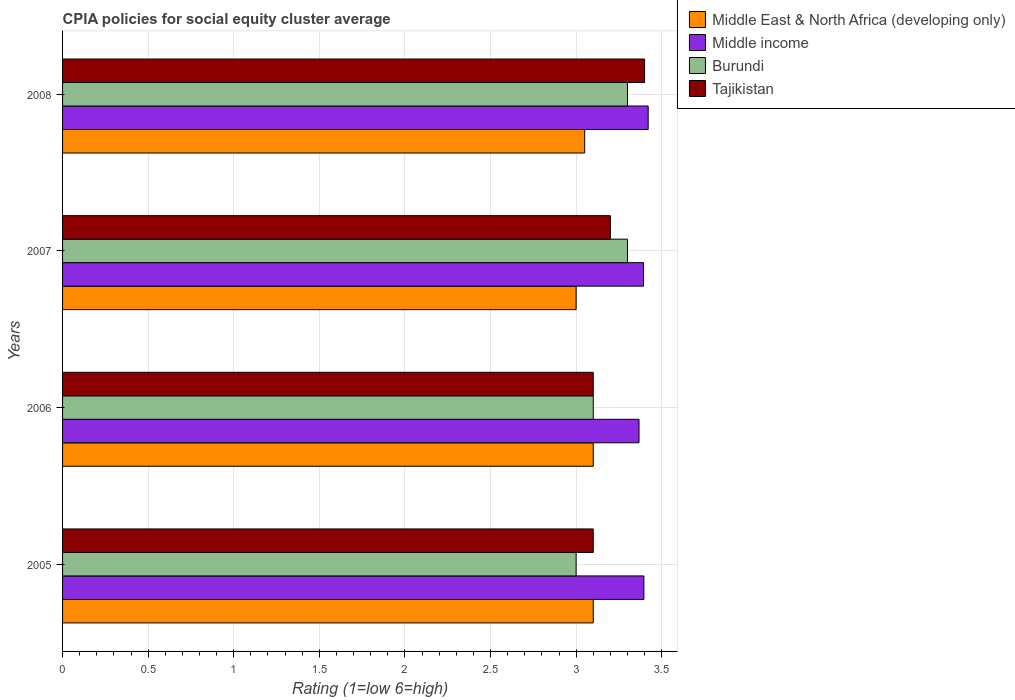Are the number of bars per tick equal to the number of legend labels?
Ensure brevity in your answer.  Yes. How many bars are there on the 1st tick from the bottom?
Provide a short and direct response. 4. In which year was the CPIA rating in Middle East & North Africa (developing only) minimum?
Make the answer very short. 2007. What is the difference between the CPIA rating in Middle East & North Africa (developing only) in 2005 and that in 2008?
Offer a very short reply. 0.05. What is the difference between the CPIA rating in Middle East & North Africa (developing only) in 2005 and the CPIA rating in Middle income in 2007?
Your answer should be very brief. -0.29. What is the average CPIA rating in Burundi per year?
Give a very brief answer. 3.17. In the year 2005, what is the difference between the CPIA rating in Burundi and CPIA rating in Middle East & North Africa (developing only)?
Provide a succinct answer. -0.1. What is the ratio of the CPIA rating in Middle income in 2007 to that in 2008?
Keep it short and to the point. 0.99. Is the difference between the CPIA rating in Burundi in 2005 and 2006 greater than the difference between the CPIA rating in Middle East & North Africa (developing only) in 2005 and 2006?
Provide a short and direct response. No. What is the difference between the highest and the lowest CPIA rating in Middle income?
Provide a short and direct response. 0.05. In how many years, is the CPIA rating in Middle East & North Africa (developing only) greater than the average CPIA rating in Middle East & North Africa (developing only) taken over all years?
Keep it short and to the point. 2. What does the 4th bar from the top in 2005 represents?
Your response must be concise. Middle East & North Africa (developing only). What does the 4th bar from the bottom in 2005 represents?
Your answer should be compact. Tajikistan. Are all the bars in the graph horizontal?
Your answer should be compact. Yes. How many years are there in the graph?
Give a very brief answer. 4. What is the difference between two consecutive major ticks on the X-axis?
Ensure brevity in your answer.  0.5. Where does the legend appear in the graph?
Offer a very short reply. Top right. What is the title of the graph?
Your response must be concise. CPIA policies for social equity cluster average. Does "Norway" appear as one of the legend labels in the graph?
Your answer should be compact. No. What is the Rating (1=low 6=high) of Middle income in 2005?
Ensure brevity in your answer.  3.4. What is the Rating (1=low 6=high) in Tajikistan in 2005?
Give a very brief answer. 3.1. What is the Rating (1=low 6=high) in Middle income in 2006?
Your answer should be very brief. 3.37. What is the Rating (1=low 6=high) in Middle East & North Africa (developing only) in 2007?
Offer a terse response. 3. What is the Rating (1=low 6=high) of Middle income in 2007?
Your response must be concise. 3.39. What is the Rating (1=low 6=high) in Burundi in 2007?
Provide a short and direct response. 3.3. What is the Rating (1=low 6=high) of Middle East & North Africa (developing only) in 2008?
Make the answer very short. 3.05. What is the Rating (1=low 6=high) in Middle income in 2008?
Your answer should be compact. 3.42. What is the Rating (1=low 6=high) in Burundi in 2008?
Offer a very short reply. 3.3. What is the Rating (1=low 6=high) of Tajikistan in 2008?
Offer a very short reply. 3.4. Across all years, what is the maximum Rating (1=low 6=high) of Middle income?
Keep it short and to the point. 3.42. Across all years, what is the maximum Rating (1=low 6=high) in Burundi?
Your response must be concise. 3.3. Across all years, what is the minimum Rating (1=low 6=high) in Middle East & North Africa (developing only)?
Provide a short and direct response. 3. Across all years, what is the minimum Rating (1=low 6=high) in Middle income?
Provide a short and direct response. 3.37. Across all years, what is the minimum Rating (1=low 6=high) in Tajikistan?
Ensure brevity in your answer.  3.1. What is the total Rating (1=low 6=high) in Middle East & North Africa (developing only) in the graph?
Your answer should be very brief. 12.25. What is the total Rating (1=low 6=high) of Middle income in the graph?
Provide a short and direct response. 13.58. What is the total Rating (1=low 6=high) of Tajikistan in the graph?
Ensure brevity in your answer.  12.8. What is the difference between the Rating (1=low 6=high) in Middle income in 2005 and that in 2006?
Make the answer very short. 0.03. What is the difference between the Rating (1=low 6=high) in Burundi in 2005 and that in 2006?
Offer a very short reply. -0.1. What is the difference between the Rating (1=low 6=high) of Tajikistan in 2005 and that in 2006?
Offer a very short reply. 0. What is the difference between the Rating (1=low 6=high) in Middle East & North Africa (developing only) in 2005 and that in 2007?
Offer a very short reply. 0.1. What is the difference between the Rating (1=low 6=high) in Middle income in 2005 and that in 2007?
Your answer should be very brief. 0. What is the difference between the Rating (1=low 6=high) of Burundi in 2005 and that in 2007?
Make the answer very short. -0.3. What is the difference between the Rating (1=low 6=high) of Tajikistan in 2005 and that in 2007?
Provide a succinct answer. -0.1. What is the difference between the Rating (1=low 6=high) in Middle income in 2005 and that in 2008?
Offer a very short reply. -0.03. What is the difference between the Rating (1=low 6=high) in Middle East & North Africa (developing only) in 2006 and that in 2007?
Offer a terse response. 0.1. What is the difference between the Rating (1=low 6=high) of Middle income in 2006 and that in 2007?
Give a very brief answer. -0.03. What is the difference between the Rating (1=low 6=high) of Burundi in 2006 and that in 2007?
Make the answer very short. -0.2. What is the difference between the Rating (1=low 6=high) of Tajikistan in 2006 and that in 2007?
Your response must be concise. -0.1. What is the difference between the Rating (1=low 6=high) of Middle East & North Africa (developing only) in 2006 and that in 2008?
Give a very brief answer. 0.05. What is the difference between the Rating (1=low 6=high) in Middle income in 2006 and that in 2008?
Your answer should be compact. -0.05. What is the difference between the Rating (1=low 6=high) in Tajikistan in 2006 and that in 2008?
Keep it short and to the point. -0.3. What is the difference between the Rating (1=low 6=high) in Middle East & North Africa (developing only) in 2007 and that in 2008?
Provide a short and direct response. -0.05. What is the difference between the Rating (1=low 6=high) of Middle income in 2007 and that in 2008?
Your answer should be compact. -0.03. What is the difference between the Rating (1=low 6=high) in Tajikistan in 2007 and that in 2008?
Keep it short and to the point. -0.2. What is the difference between the Rating (1=low 6=high) in Middle East & North Africa (developing only) in 2005 and the Rating (1=low 6=high) in Middle income in 2006?
Provide a succinct answer. -0.27. What is the difference between the Rating (1=low 6=high) in Middle East & North Africa (developing only) in 2005 and the Rating (1=low 6=high) in Burundi in 2006?
Keep it short and to the point. 0. What is the difference between the Rating (1=low 6=high) of Middle East & North Africa (developing only) in 2005 and the Rating (1=low 6=high) of Tajikistan in 2006?
Ensure brevity in your answer.  0. What is the difference between the Rating (1=low 6=high) of Middle income in 2005 and the Rating (1=low 6=high) of Burundi in 2006?
Ensure brevity in your answer.  0.3. What is the difference between the Rating (1=low 6=high) in Middle income in 2005 and the Rating (1=low 6=high) in Tajikistan in 2006?
Provide a short and direct response. 0.3. What is the difference between the Rating (1=low 6=high) in Burundi in 2005 and the Rating (1=low 6=high) in Tajikistan in 2006?
Provide a succinct answer. -0.1. What is the difference between the Rating (1=low 6=high) of Middle East & North Africa (developing only) in 2005 and the Rating (1=low 6=high) of Middle income in 2007?
Make the answer very short. -0.29. What is the difference between the Rating (1=low 6=high) of Middle East & North Africa (developing only) in 2005 and the Rating (1=low 6=high) of Tajikistan in 2007?
Your answer should be very brief. -0.1. What is the difference between the Rating (1=low 6=high) of Middle income in 2005 and the Rating (1=low 6=high) of Burundi in 2007?
Your answer should be very brief. 0.1. What is the difference between the Rating (1=low 6=high) in Middle income in 2005 and the Rating (1=low 6=high) in Tajikistan in 2007?
Your answer should be very brief. 0.2. What is the difference between the Rating (1=low 6=high) in Burundi in 2005 and the Rating (1=low 6=high) in Tajikistan in 2007?
Keep it short and to the point. -0.2. What is the difference between the Rating (1=low 6=high) of Middle East & North Africa (developing only) in 2005 and the Rating (1=low 6=high) of Middle income in 2008?
Your answer should be very brief. -0.32. What is the difference between the Rating (1=low 6=high) of Middle East & North Africa (developing only) in 2005 and the Rating (1=low 6=high) of Burundi in 2008?
Provide a short and direct response. -0.2. What is the difference between the Rating (1=low 6=high) of Middle East & North Africa (developing only) in 2005 and the Rating (1=low 6=high) of Tajikistan in 2008?
Make the answer very short. -0.3. What is the difference between the Rating (1=low 6=high) in Middle income in 2005 and the Rating (1=low 6=high) in Burundi in 2008?
Your response must be concise. 0.1. What is the difference between the Rating (1=low 6=high) of Middle income in 2005 and the Rating (1=low 6=high) of Tajikistan in 2008?
Give a very brief answer. -0. What is the difference between the Rating (1=low 6=high) of Burundi in 2005 and the Rating (1=low 6=high) of Tajikistan in 2008?
Provide a succinct answer. -0.4. What is the difference between the Rating (1=low 6=high) in Middle East & North Africa (developing only) in 2006 and the Rating (1=low 6=high) in Middle income in 2007?
Your answer should be very brief. -0.29. What is the difference between the Rating (1=low 6=high) in Middle East & North Africa (developing only) in 2006 and the Rating (1=low 6=high) in Burundi in 2007?
Provide a succinct answer. -0.2. What is the difference between the Rating (1=low 6=high) of Middle income in 2006 and the Rating (1=low 6=high) of Burundi in 2007?
Your response must be concise. 0.07. What is the difference between the Rating (1=low 6=high) in Middle income in 2006 and the Rating (1=low 6=high) in Tajikistan in 2007?
Your answer should be compact. 0.17. What is the difference between the Rating (1=low 6=high) of Middle East & North Africa (developing only) in 2006 and the Rating (1=low 6=high) of Middle income in 2008?
Provide a short and direct response. -0.32. What is the difference between the Rating (1=low 6=high) in Middle income in 2006 and the Rating (1=low 6=high) in Burundi in 2008?
Your answer should be compact. 0.07. What is the difference between the Rating (1=low 6=high) in Middle income in 2006 and the Rating (1=low 6=high) in Tajikistan in 2008?
Make the answer very short. -0.03. What is the difference between the Rating (1=low 6=high) in Middle East & North Africa (developing only) in 2007 and the Rating (1=low 6=high) in Middle income in 2008?
Provide a short and direct response. -0.42. What is the difference between the Rating (1=low 6=high) of Middle East & North Africa (developing only) in 2007 and the Rating (1=low 6=high) of Burundi in 2008?
Your response must be concise. -0.3. What is the difference between the Rating (1=low 6=high) in Middle income in 2007 and the Rating (1=low 6=high) in Burundi in 2008?
Offer a very short reply. 0.09. What is the difference between the Rating (1=low 6=high) of Middle income in 2007 and the Rating (1=low 6=high) of Tajikistan in 2008?
Offer a terse response. -0.01. What is the average Rating (1=low 6=high) in Middle East & North Africa (developing only) per year?
Give a very brief answer. 3.06. What is the average Rating (1=low 6=high) in Middle income per year?
Offer a terse response. 3.39. What is the average Rating (1=low 6=high) in Burundi per year?
Offer a very short reply. 3.17. In the year 2005, what is the difference between the Rating (1=low 6=high) in Middle East & North Africa (developing only) and Rating (1=low 6=high) in Middle income?
Provide a succinct answer. -0.3. In the year 2005, what is the difference between the Rating (1=low 6=high) in Middle East & North Africa (developing only) and Rating (1=low 6=high) in Tajikistan?
Give a very brief answer. 0. In the year 2005, what is the difference between the Rating (1=low 6=high) of Middle income and Rating (1=low 6=high) of Burundi?
Your response must be concise. 0.4. In the year 2005, what is the difference between the Rating (1=low 6=high) of Middle income and Rating (1=low 6=high) of Tajikistan?
Offer a terse response. 0.3. In the year 2006, what is the difference between the Rating (1=low 6=high) in Middle East & North Africa (developing only) and Rating (1=low 6=high) in Middle income?
Provide a succinct answer. -0.27. In the year 2006, what is the difference between the Rating (1=low 6=high) of Middle East & North Africa (developing only) and Rating (1=low 6=high) of Tajikistan?
Keep it short and to the point. 0. In the year 2006, what is the difference between the Rating (1=low 6=high) in Middle income and Rating (1=low 6=high) in Burundi?
Provide a succinct answer. 0.27. In the year 2006, what is the difference between the Rating (1=low 6=high) of Middle income and Rating (1=low 6=high) of Tajikistan?
Keep it short and to the point. 0.27. In the year 2006, what is the difference between the Rating (1=low 6=high) of Burundi and Rating (1=low 6=high) of Tajikistan?
Offer a terse response. 0. In the year 2007, what is the difference between the Rating (1=low 6=high) of Middle East & North Africa (developing only) and Rating (1=low 6=high) of Middle income?
Keep it short and to the point. -0.39. In the year 2007, what is the difference between the Rating (1=low 6=high) of Middle East & North Africa (developing only) and Rating (1=low 6=high) of Tajikistan?
Provide a short and direct response. -0.2. In the year 2007, what is the difference between the Rating (1=low 6=high) in Middle income and Rating (1=low 6=high) in Burundi?
Keep it short and to the point. 0.09. In the year 2007, what is the difference between the Rating (1=low 6=high) of Middle income and Rating (1=low 6=high) of Tajikistan?
Offer a terse response. 0.19. In the year 2007, what is the difference between the Rating (1=low 6=high) of Burundi and Rating (1=low 6=high) of Tajikistan?
Keep it short and to the point. 0.1. In the year 2008, what is the difference between the Rating (1=low 6=high) in Middle East & North Africa (developing only) and Rating (1=low 6=high) in Middle income?
Provide a short and direct response. -0.37. In the year 2008, what is the difference between the Rating (1=low 6=high) in Middle East & North Africa (developing only) and Rating (1=low 6=high) in Tajikistan?
Your response must be concise. -0.35. In the year 2008, what is the difference between the Rating (1=low 6=high) in Middle income and Rating (1=low 6=high) in Burundi?
Your response must be concise. 0.12. In the year 2008, what is the difference between the Rating (1=low 6=high) of Middle income and Rating (1=low 6=high) of Tajikistan?
Make the answer very short. 0.02. In the year 2008, what is the difference between the Rating (1=low 6=high) in Burundi and Rating (1=low 6=high) in Tajikistan?
Provide a short and direct response. -0.1. What is the ratio of the Rating (1=low 6=high) of Middle East & North Africa (developing only) in 2005 to that in 2006?
Provide a short and direct response. 1. What is the ratio of the Rating (1=low 6=high) of Middle income in 2005 to that in 2006?
Give a very brief answer. 1.01. What is the ratio of the Rating (1=low 6=high) in Tajikistan in 2005 to that in 2006?
Give a very brief answer. 1. What is the ratio of the Rating (1=low 6=high) of Tajikistan in 2005 to that in 2007?
Offer a very short reply. 0.97. What is the ratio of the Rating (1=low 6=high) in Middle East & North Africa (developing only) in 2005 to that in 2008?
Give a very brief answer. 1.02. What is the ratio of the Rating (1=low 6=high) in Middle income in 2005 to that in 2008?
Your answer should be very brief. 0.99. What is the ratio of the Rating (1=low 6=high) in Tajikistan in 2005 to that in 2008?
Ensure brevity in your answer.  0.91. What is the ratio of the Rating (1=low 6=high) in Middle income in 2006 to that in 2007?
Your answer should be very brief. 0.99. What is the ratio of the Rating (1=low 6=high) of Burundi in 2006 to that in 2007?
Your answer should be compact. 0.94. What is the ratio of the Rating (1=low 6=high) of Tajikistan in 2006 to that in 2007?
Offer a very short reply. 0.97. What is the ratio of the Rating (1=low 6=high) of Middle East & North Africa (developing only) in 2006 to that in 2008?
Your answer should be compact. 1.02. What is the ratio of the Rating (1=low 6=high) of Middle income in 2006 to that in 2008?
Make the answer very short. 0.98. What is the ratio of the Rating (1=low 6=high) of Burundi in 2006 to that in 2008?
Your answer should be compact. 0.94. What is the ratio of the Rating (1=low 6=high) in Tajikistan in 2006 to that in 2008?
Offer a terse response. 0.91. What is the ratio of the Rating (1=low 6=high) in Middle East & North Africa (developing only) in 2007 to that in 2008?
Offer a terse response. 0.98. What is the difference between the highest and the second highest Rating (1=low 6=high) in Middle East & North Africa (developing only)?
Your answer should be compact. 0. What is the difference between the highest and the second highest Rating (1=low 6=high) of Middle income?
Provide a short and direct response. 0.03. What is the difference between the highest and the second highest Rating (1=low 6=high) of Burundi?
Provide a short and direct response. 0. What is the difference between the highest and the second highest Rating (1=low 6=high) of Tajikistan?
Provide a succinct answer. 0.2. What is the difference between the highest and the lowest Rating (1=low 6=high) of Middle East & North Africa (developing only)?
Give a very brief answer. 0.1. What is the difference between the highest and the lowest Rating (1=low 6=high) in Middle income?
Offer a very short reply. 0.05. What is the difference between the highest and the lowest Rating (1=low 6=high) in Tajikistan?
Provide a short and direct response. 0.3. 